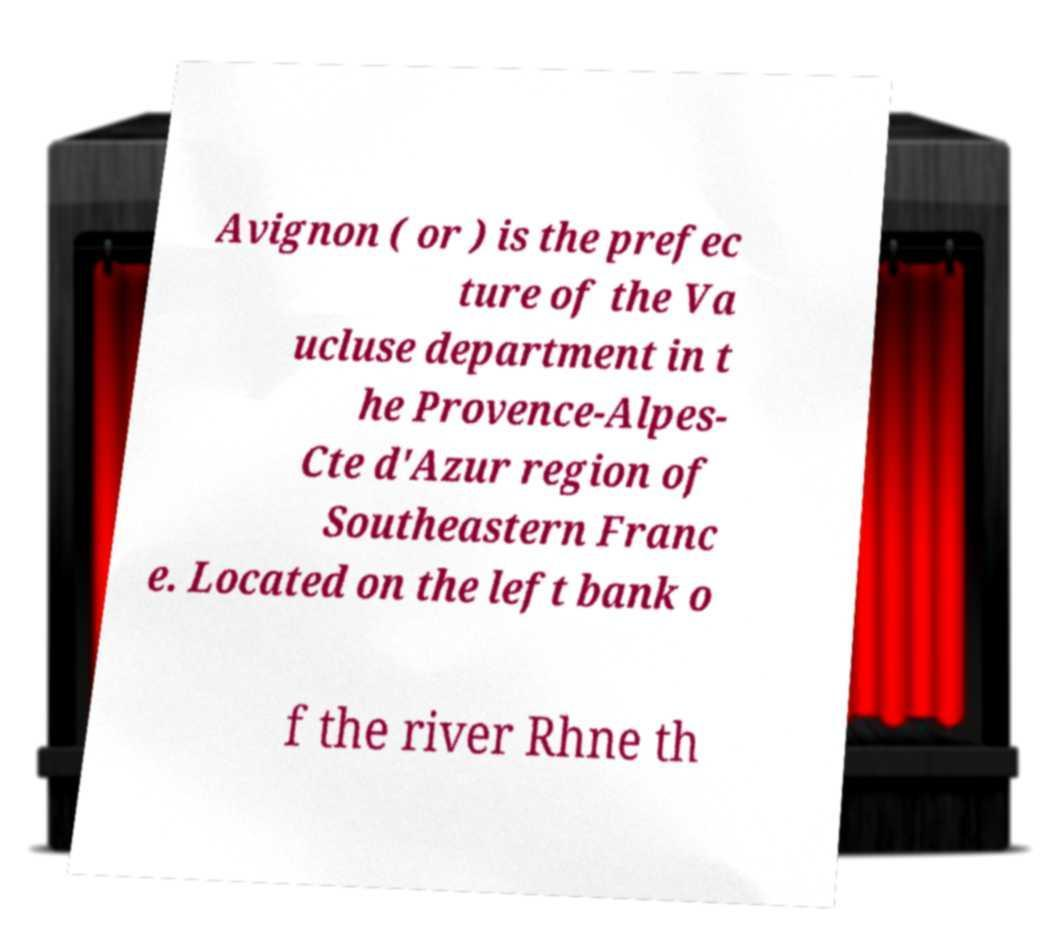Can you accurately transcribe the text from the provided image for me? Avignon ( or ) is the prefec ture of the Va ucluse department in t he Provence-Alpes- Cte d'Azur region of Southeastern Franc e. Located on the left bank o f the river Rhne th 